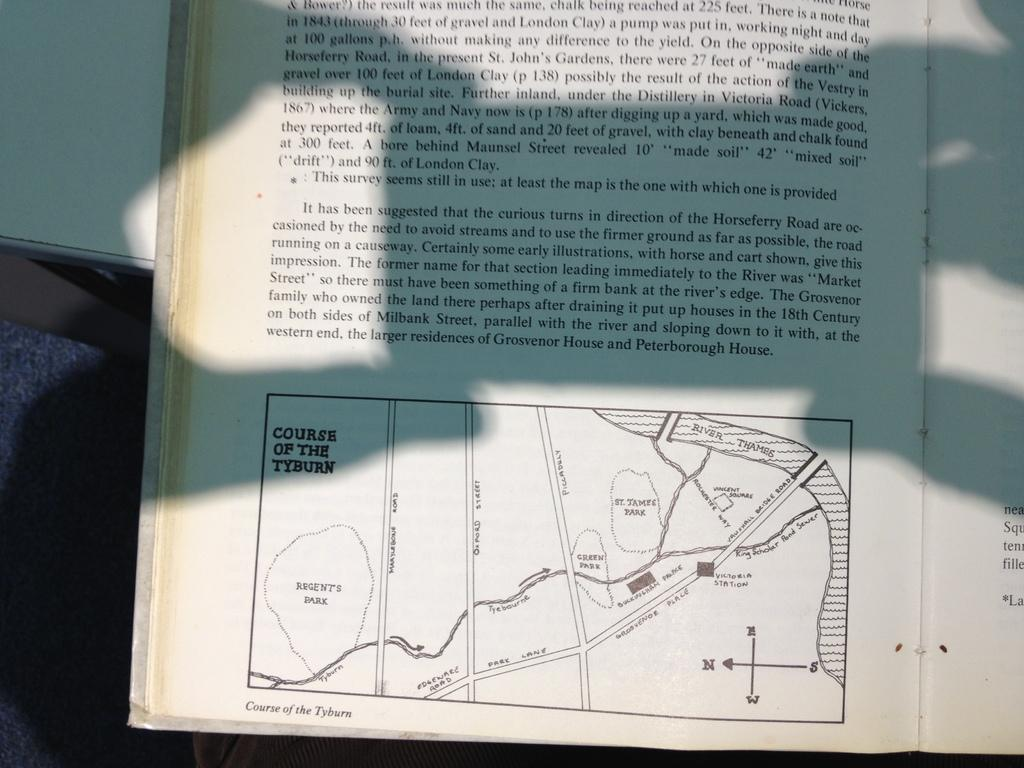<image>
Give a short and clear explanation of the subsequent image. A map shows the courses of the Tyburn. 